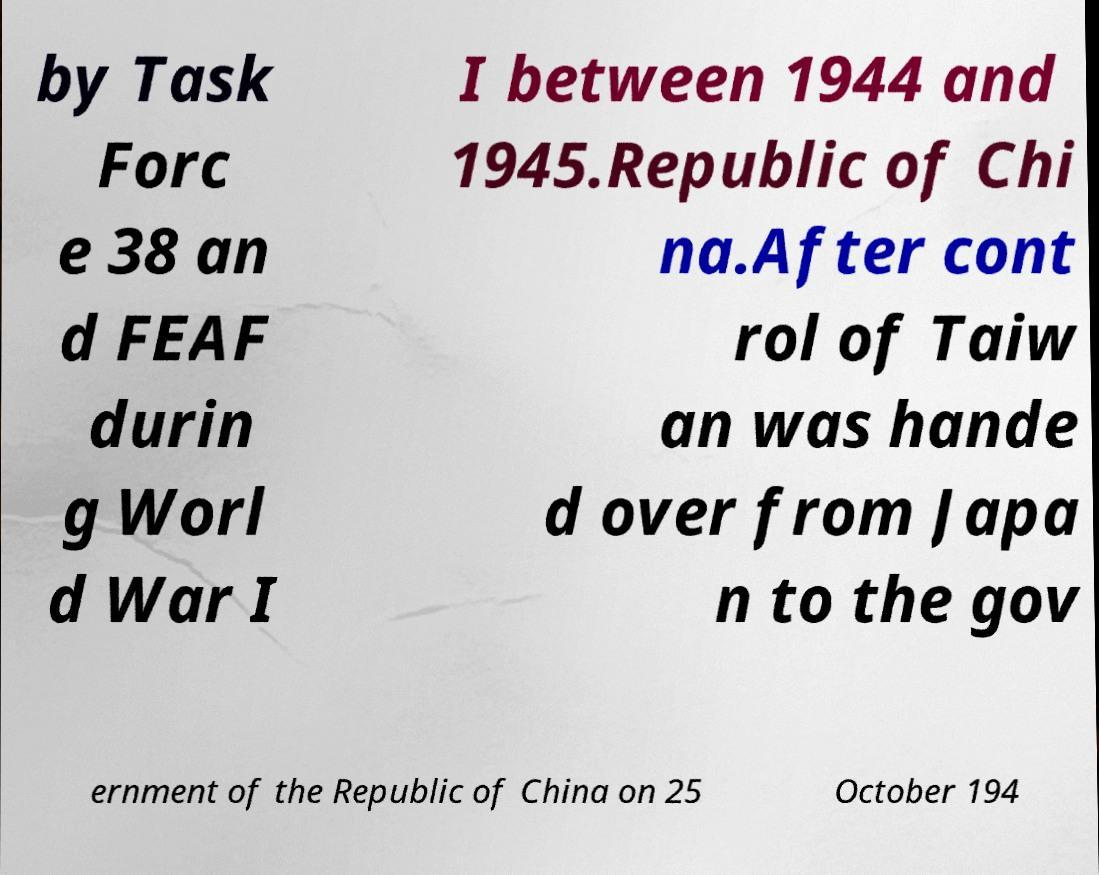Can you read and provide the text displayed in the image?This photo seems to have some interesting text. Can you extract and type it out for me? by Task Forc e 38 an d FEAF durin g Worl d War I I between 1944 and 1945.Republic of Chi na.After cont rol of Taiw an was hande d over from Japa n to the gov ernment of the Republic of China on 25 October 194 